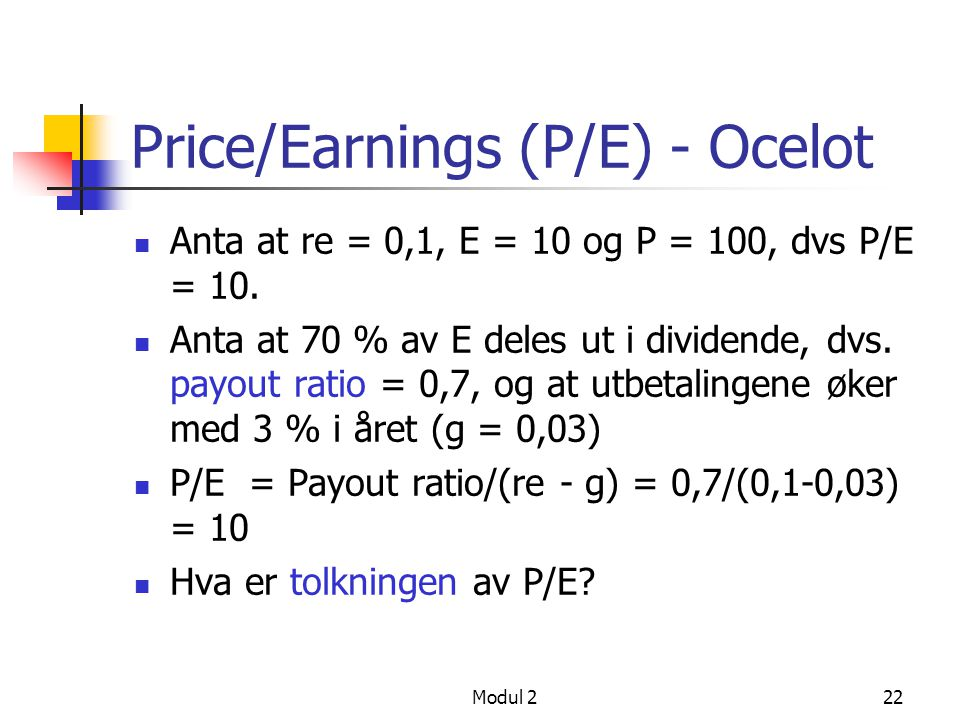How is the concept of payout ratio crucial in evaluating a company's financial health? The payout ratio is a key metric in assessing a company's financial health because it indicates the proportion of earnings paid out as dividends. A moderate payout ratio suggests a balanced approach where the company retains enough earnings for growth while also rewarding shareholders. A very high payout ratio might indicate that the company is choosing to distribute most of its earnings and might have limited reinvestment opportunities, common among mature companies. Conversely, a very low payout ratio could indicate that the company is reinvesting a significant portion of its earnings into future growth. 